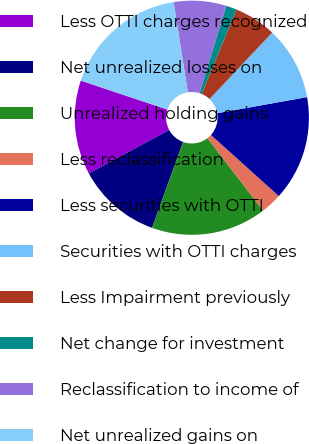Convert chart to OTSL. <chart><loc_0><loc_0><loc_500><loc_500><pie_chart><fcel>Less OTTI charges recognized<fcel>Net unrealized losses on<fcel>Unrealized holding gains<fcel>Less reclassification<fcel>Less securities with OTTI<fcel>Securities with OTTI charges<fcel>Less Impairment previously<fcel>Net change for investment<fcel>Reclassification to income of<fcel>Net unrealized gains on<nl><fcel>13.03%<fcel>11.59%<fcel>15.93%<fcel>2.92%<fcel>14.48%<fcel>10.14%<fcel>5.81%<fcel>1.47%<fcel>7.25%<fcel>17.37%<nl></chart> 